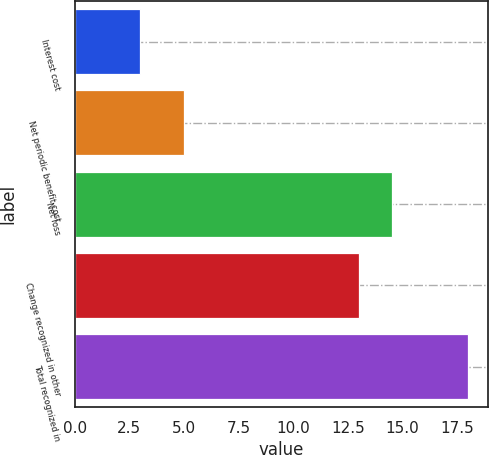Convert chart. <chart><loc_0><loc_0><loc_500><loc_500><bar_chart><fcel>Interest cost<fcel>Net periodic benefit cost<fcel>Net loss<fcel>Change recognized in other<fcel>Total recognized in<nl><fcel>3<fcel>5<fcel>14.5<fcel>13<fcel>18<nl></chart> 